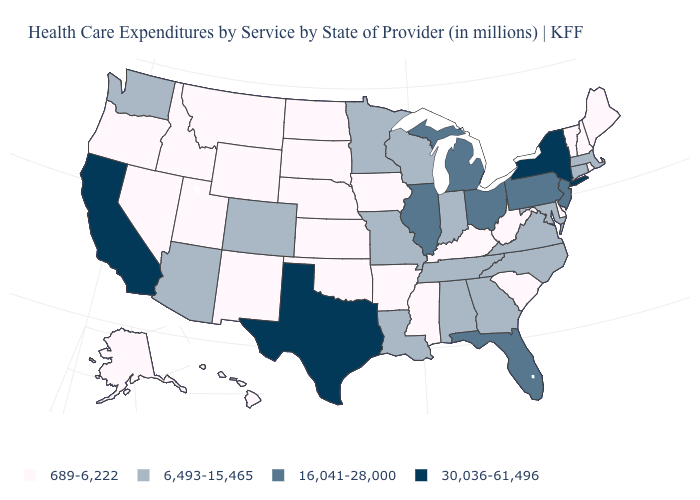Name the states that have a value in the range 689-6,222?
Short answer required. Alaska, Arkansas, Delaware, Hawaii, Idaho, Iowa, Kansas, Kentucky, Maine, Mississippi, Montana, Nebraska, Nevada, New Hampshire, New Mexico, North Dakota, Oklahoma, Oregon, Rhode Island, South Carolina, South Dakota, Utah, Vermont, West Virginia, Wyoming. Name the states that have a value in the range 689-6,222?
Be succinct. Alaska, Arkansas, Delaware, Hawaii, Idaho, Iowa, Kansas, Kentucky, Maine, Mississippi, Montana, Nebraska, Nevada, New Hampshire, New Mexico, North Dakota, Oklahoma, Oregon, Rhode Island, South Carolina, South Dakota, Utah, Vermont, West Virginia, Wyoming. Name the states that have a value in the range 689-6,222?
Give a very brief answer. Alaska, Arkansas, Delaware, Hawaii, Idaho, Iowa, Kansas, Kentucky, Maine, Mississippi, Montana, Nebraska, Nevada, New Hampshire, New Mexico, North Dakota, Oklahoma, Oregon, Rhode Island, South Carolina, South Dakota, Utah, Vermont, West Virginia, Wyoming. Name the states that have a value in the range 6,493-15,465?
Be succinct. Alabama, Arizona, Colorado, Connecticut, Georgia, Indiana, Louisiana, Maryland, Massachusetts, Minnesota, Missouri, North Carolina, Tennessee, Virginia, Washington, Wisconsin. Among the states that border Oklahoma , which have the highest value?
Concise answer only. Texas. Does New York have the highest value in the USA?
Write a very short answer. Yes. What is the value of Arizona?
Give a very brief answer. 6,493-15,465. Among the states that border Iowa , which have the highest value?
Concise answer only. Illinois. Does Virginia have a lower value than Wisconsin?
Write a very short answer. No. What is the value of California?
Answer briefly. 30,036-61,496. Among the states that border Indiana , which have the lowest value?
Keep it brief. Kentucky. Among the states that border Connecticut , which have the lowest value?
Quick response, please. Rhode Island. What is the lowest value in the USA?
Give a very brief answer. 689-6,222. What is the highest value in states that border Utah?
Short answer required. 6,493-15,465. Does the first symbol in the legend represent the smallest category?
Give a very brief answer. Yes. 